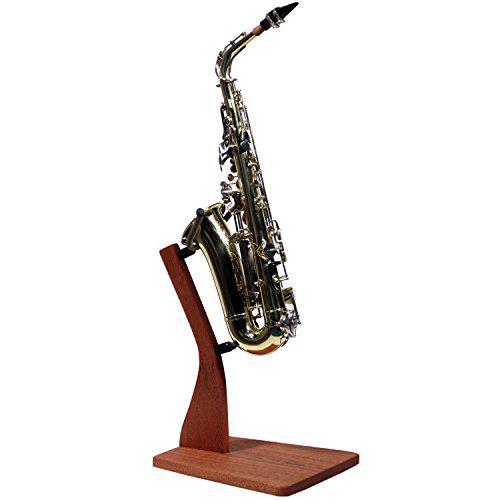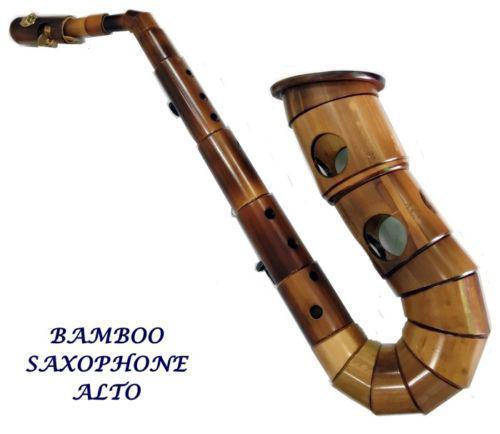The first image is the image on the left, the second image is the image on the right. For the images shown, is this caption "The saxophone in the image on the left is on a stand." true? Answer yes or no. Yes. The first image is the image on the left, the second image is the image on the right. For the images displayed, is the sentence "The left image shows one instrument displayed on a wooden stand." factually correct? Answer yes or no. Yes. 